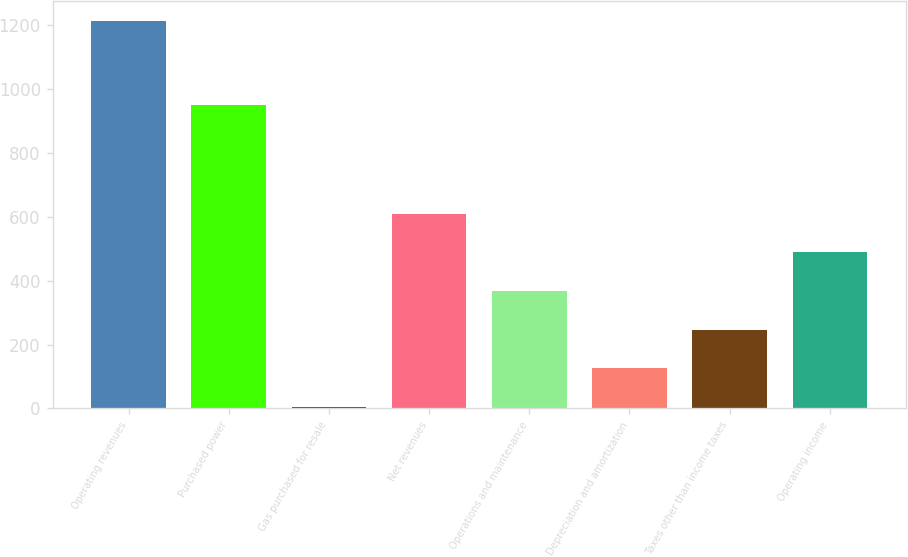Convert chart to OTSL. <chart><loc_0><loc_0><loc_500><loc_500><bar_chart><fcel>Operating revenues<fcel>Purchased power<fcel>Gas purchased for resale<fcel>Net revenues<fcel>Operations and maintenance<fcel>Depreciation and amortization<fcel>Taxes other than income taxes<fcel>Operating income<nl><fcel>1213<fcel>950<fcel>5<fcel>609<fcel>367.4<fcel>125.8<fcel>246.6<fcel>488.2<nl></chart> 